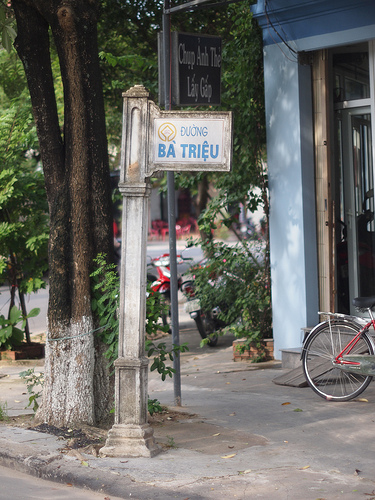Please provide a short description for this region: [0.72, 0.52, 0.87, 0.85]. The region [0.72, 0.52, 0.87, 0.85] contains a bike at the sidewalk. 